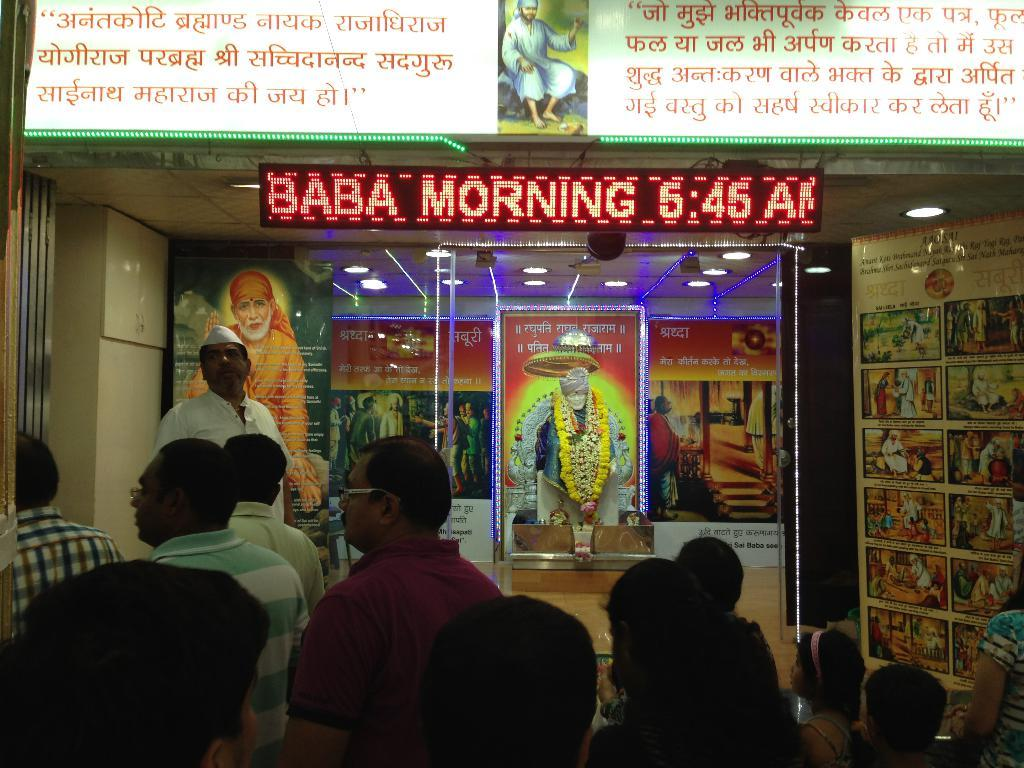What can be seen at the bottom of the image? There are people at the bottom side of the image. What is the main object in the center of the image? There is a statue in the center of the image. What type of illumination is present in the image? There are lights in the image. What type of printed material can be seen in the image? There are posters in the image. How many pears are on the statue in the image? There are no pears present on the statue in the image. What type of health advice is given on the posters in the image? There is no health advice provided on the posters in the image; they are not related to health. 